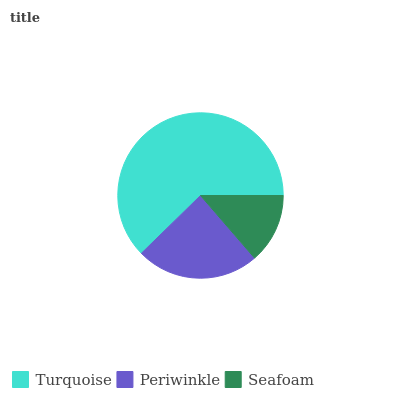Is Seafoam the minimum?
Answer yes or no. Yes. Is Turquoise the maximum?
Answer yes or no. Yes. Is Periwinkle the minimum?
Answer yes or no. No. Is Periwinkle the maximum?
Answer yes or no. No. Is Turquoise greater than Periwinkle?
Answer yes or no. Yes. Is Periwinkle less than Turquoise?
Answer yes or no. Yes. Is Periwinkle greater than Turquoise?
Answer yes or no. No. Is Turquoise less than Periwinkle?
Answer yes or no. No. Is Periwinkle the high median?
Answer yes or no. Yes. Is Periwinkle the low median?
Answer yes or no. Yes. Is Turquoise the high median?
Answer yes or no. No. Is Seafoam the low median?
Answer yes or no. No. 